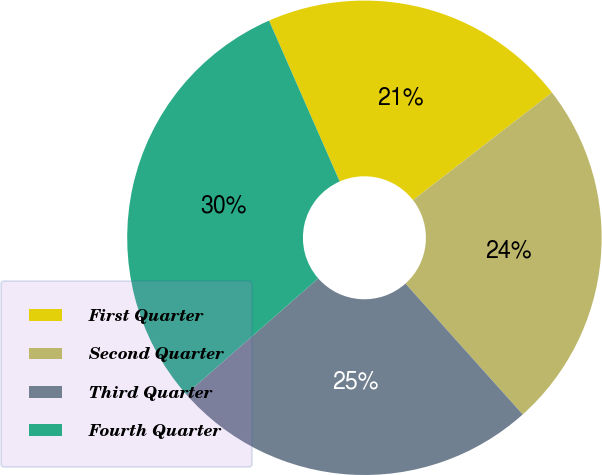Convert chart to OTSL. <chart><loc_0><loc_0><loc_500><loc_500><pie_chart><fcel>First Quarter<fcel>Second Quarter<fcel>Third Quarter<fcel>Fourth Quarter<nl><fcel>21.1%<fcel>23.86%<fcel>25.17%<fcel>29.87%<nl></chart> 